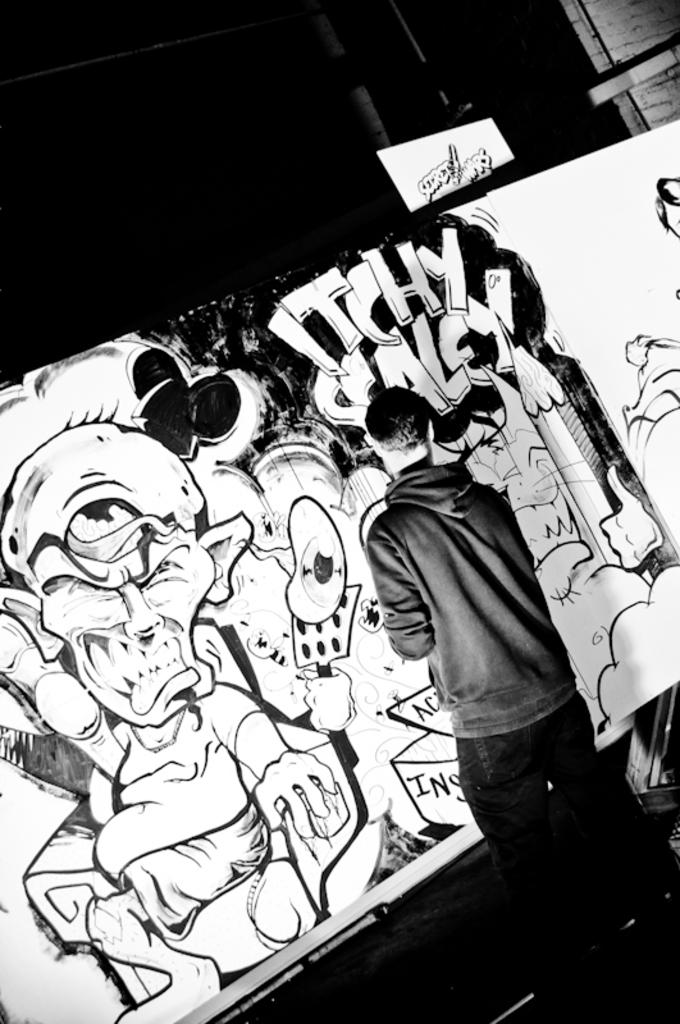What is the man in the image doing? The man is drawing on a board in the image. What is the color scheme of the image? The image is in black and white. What type of clothing is the man wearing on his upper body? The man is wearing a sweater. What type of clothing is the man wearing on his lower body? The man is wearing trousers. Can you tell me how many snakes are slithering around the man's feet in the image? There are no snakes present in the image; the man is simply drawing on a board. What type of credit does the man have in the image? There is no reference to credit or any financial information in the image. 